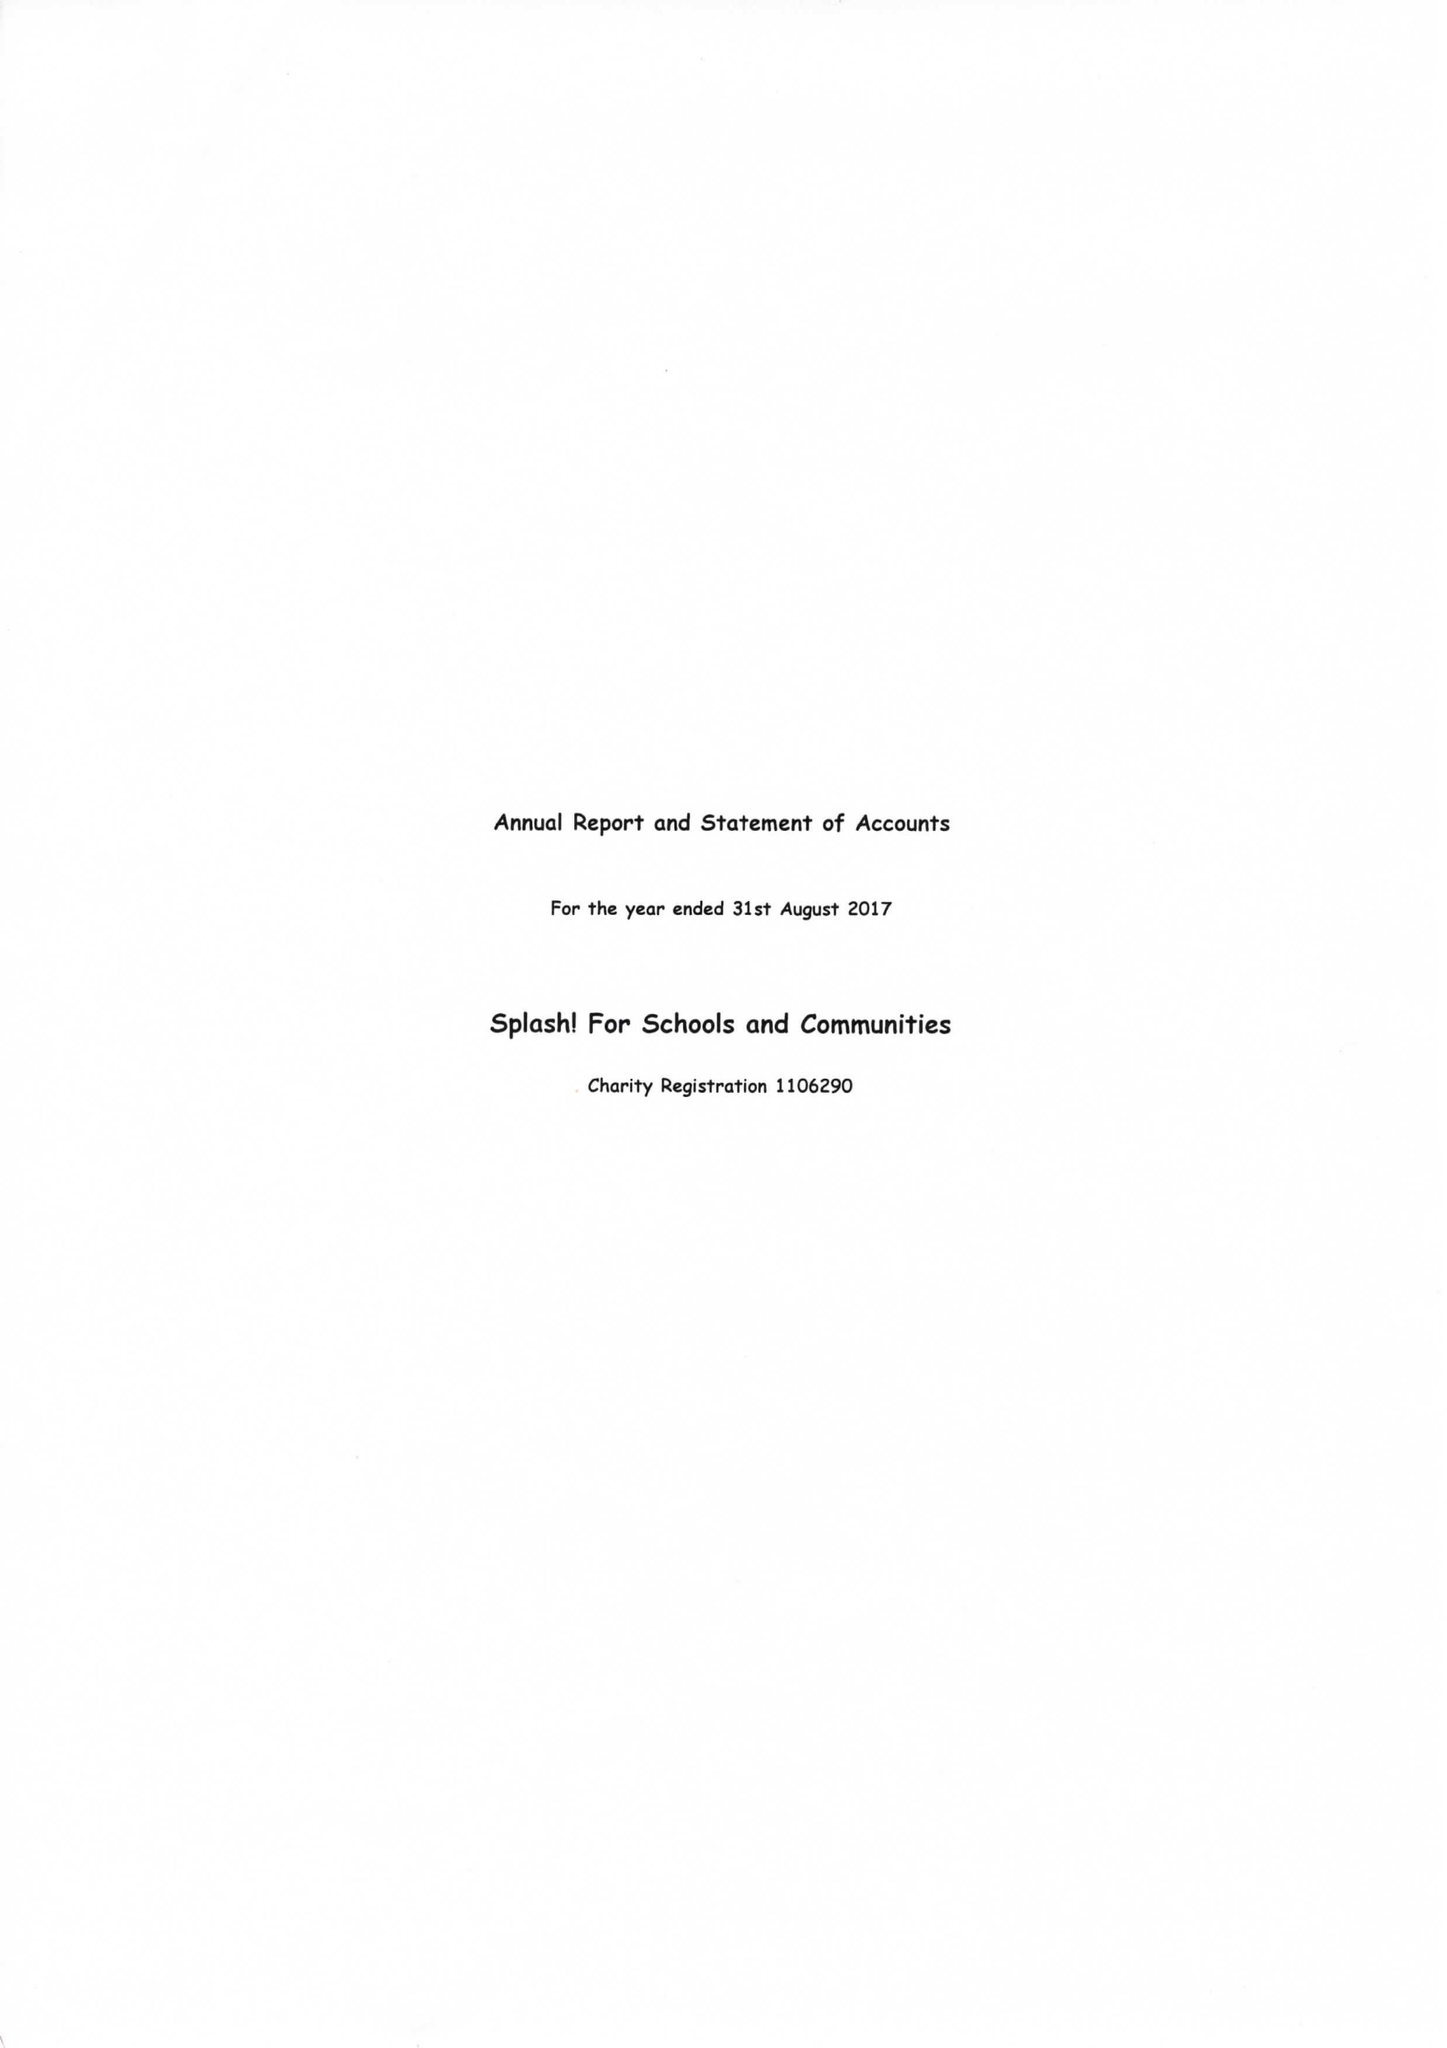What is the value for the report_date?
Answer the question using a single word or phrase. 2017-08-31 